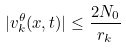Convert formula to latex. <formula><loc_0><loc_0><loc_500><loc_500>| v ^ { \theta } _ { k } ( x , t ) | \leq \frac { 2 N _ { 0 } } { r _ { k } }</formula> 